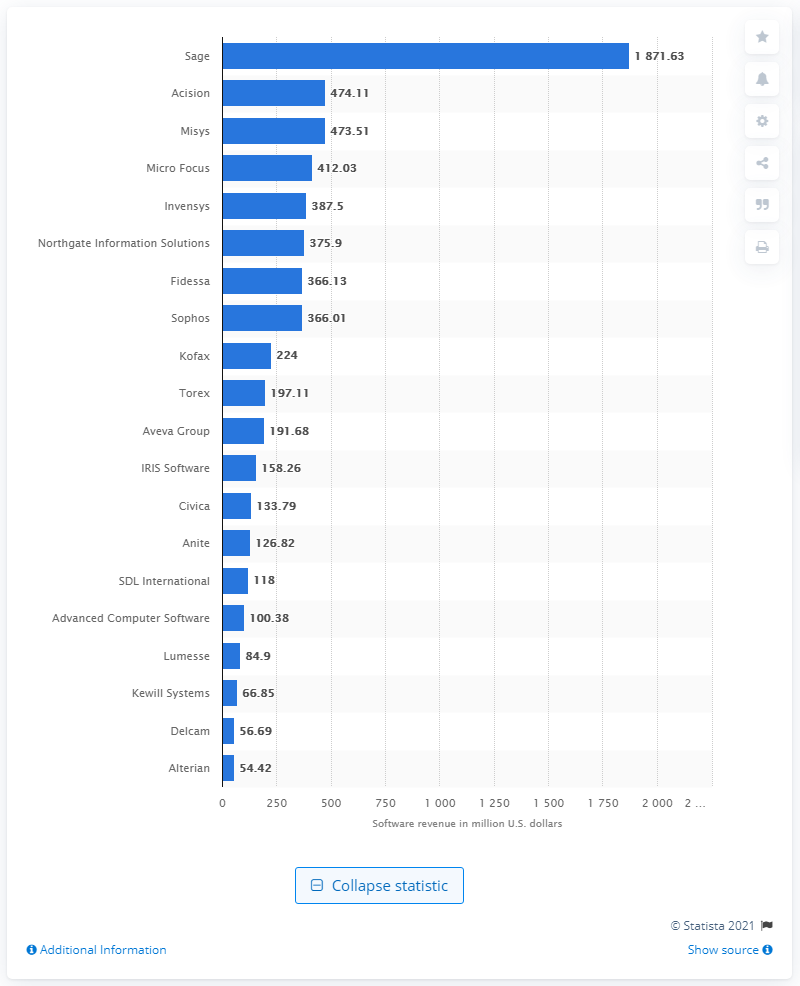Specify some key components in this picture. In 2011, Sage was the top performing software company in the United Kingdom. 